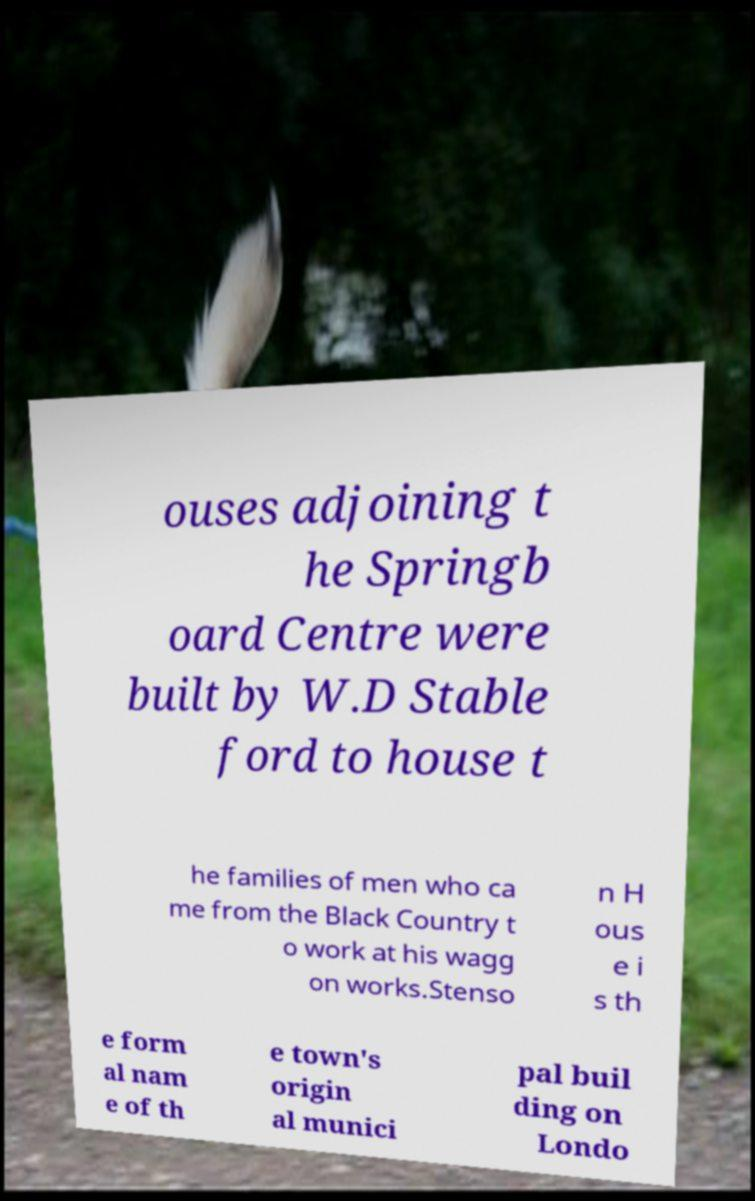For documentation purposes, I need the text within this image transcribed. Could you provide that? ouses adjoining t he Springb oard Centre were built by W.D Stable ford to house t he families of men who ca me from the Black Country t o work at his wagg on works.Stenso n H ous e i s th e form al nam e of th e town's origin al munici pal buil ding on Londo 